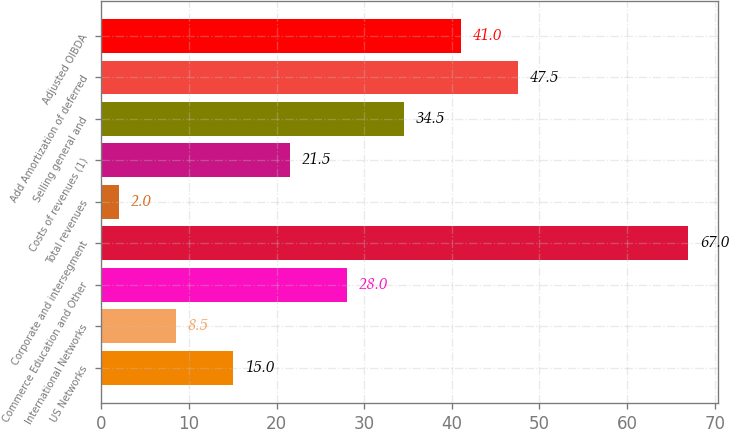Convert chart. <chart><loc_0><loc_0><loc_500><loc_500><bar_chart><fcel>US Networks<fcel>International Networks<fcel>Commerce Education and Other<fcel>Corporate and intersegment<fcel>Total revenues<fcel>Costs of revenues (1)<fcel>Selling general and<fcel>Add Amortization of deferred<fcel>Adjusted OIBDA<nl><fcel>15<fcel>8.5<fcel>28<fcel>67<fcel>2<fcel>21.5<fcel>34.5<fcel>47.5<fcel>41<nl></chart> 